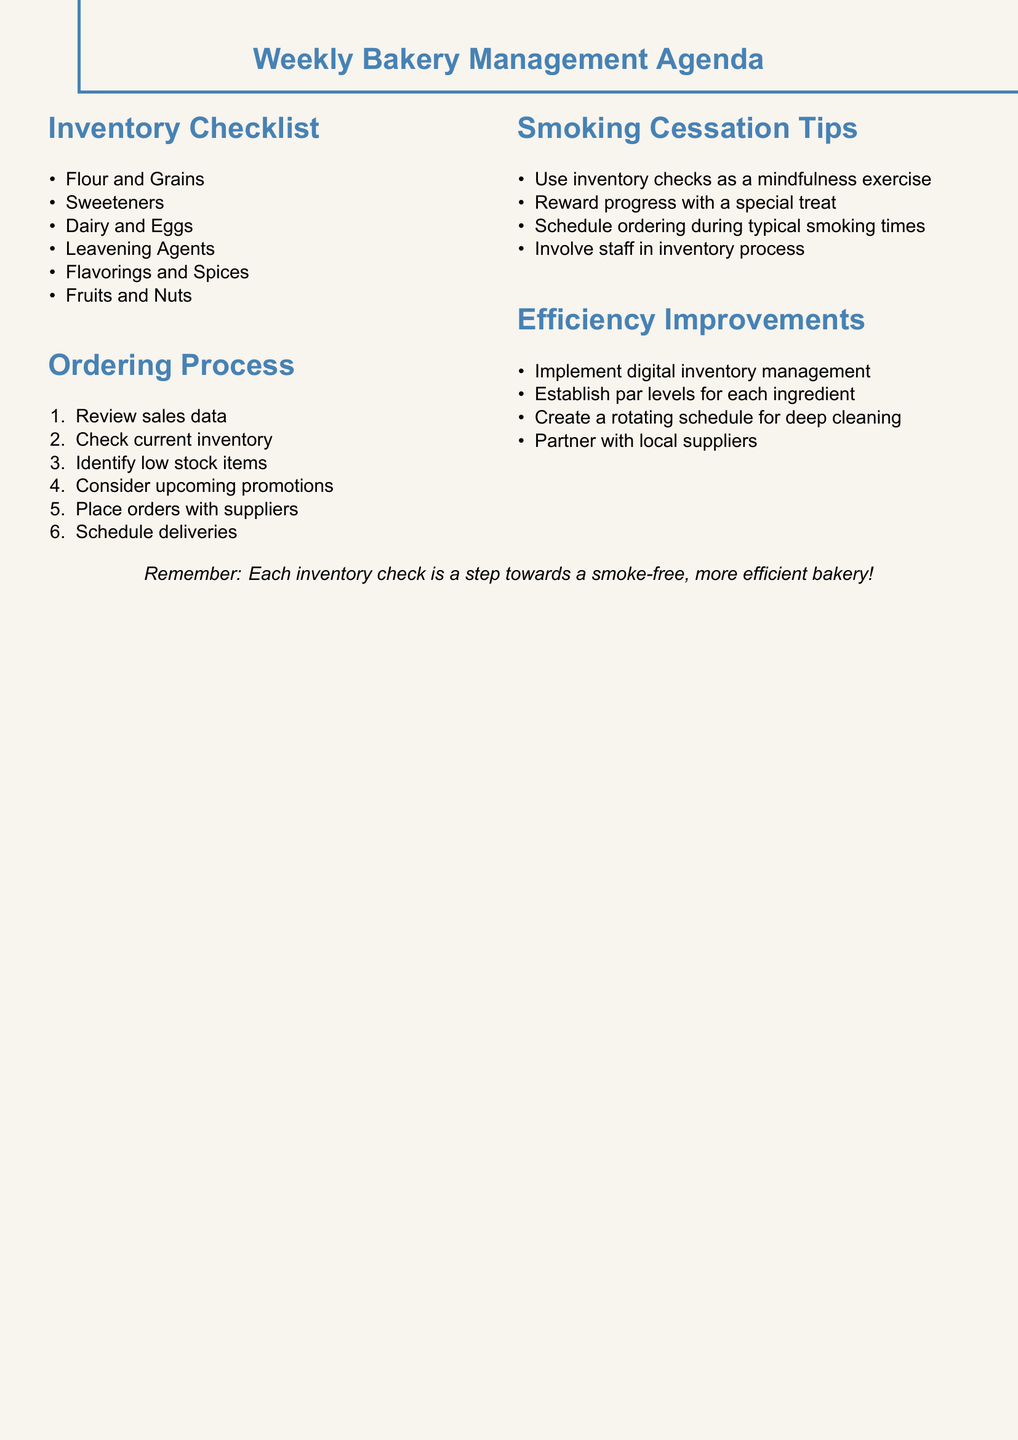What is the first category listed in the inventory checklist? The first category is mentioned at the top of the inventory checklist, which is "Flour and Grains."
Answer: Flour and Grains How many items are listed under Sweeteners? The number of items under Sweeteners can be counted directly from the checklist, which includes five items.
Answer: 5 What step comes after "Check current inventory" in the ordering process? The ordering process is structured in a sequential manner, and the step that follows is "Identify low stock items."
Answer: Identify low stock items Which suppliers are mentioned for placing orders? The document provides specific suppliers for placing orders, namely "King Arthur Flour, Sysco, and local farms."
Answer: King Arthur Flour, Sysco, and local farms What should be scheduled during typical smoking times? The document advises to replace smoking habits with a productive activity, specifically stating to schedule "ordering."
Answer: Ordering What is one recommendation for improving efficiency? Suggestions for efficiency are included at the end of the document; one such suggestion is to "Implement digital inventory management."
Answer: Implement digital inventory management How can the inventory check be utilized as part of smoking cessation? The document suggests that inventory checks can serve a dual purpose, specifically as a "mindfulness exercise."
Answer: Mindfulness exercise What type of treat should be given as a reward for progress? The document mentions that progress can be celebrated with a "special treat."
Answer: Special treat 